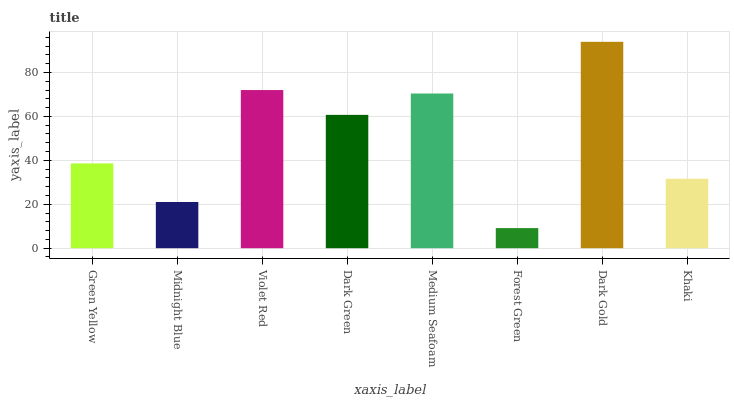Is Forest Green the minimum?
Answer yes or no. Yes. Is Dark Gold the maximum?
Answer yes or no. Yes. Is Midnight Blue the minimum?
Answer yes or no. No. Is Midnight Blue the maximum?
Answer yes or no. No. Is Green Yellow greater than Midnight Blue?
Answer yes or no. Yes. Is Midnight Blue less than Green Yellow?
Answer yes or no. Yes. Is Midnight Blue greater than Green Yellow?
Answer yes or no. No. Is Green Yellow less than Midnight Blue?
Answer yes or no. No. Is Dark Green the high median?
Answer yes or no. Yes. Is Green Yellow the low median?
Answer yes or no. Yes. Is Forest Green the high median?
Answer yes or no. No. Is Medium Seafoam the low median?
Answer yes or no. No. 